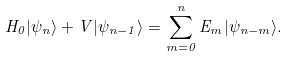<formula> <loc_0><loc_0><loc_500><loc_500>H _ { 0 } | \psi _ { n } \rangle + V | \psi _ { n - 1 } \rangle = \sum _ { m = 0 } ^ { n } E _ { m } | \psi _ { n - m } \rangle .</formula> 